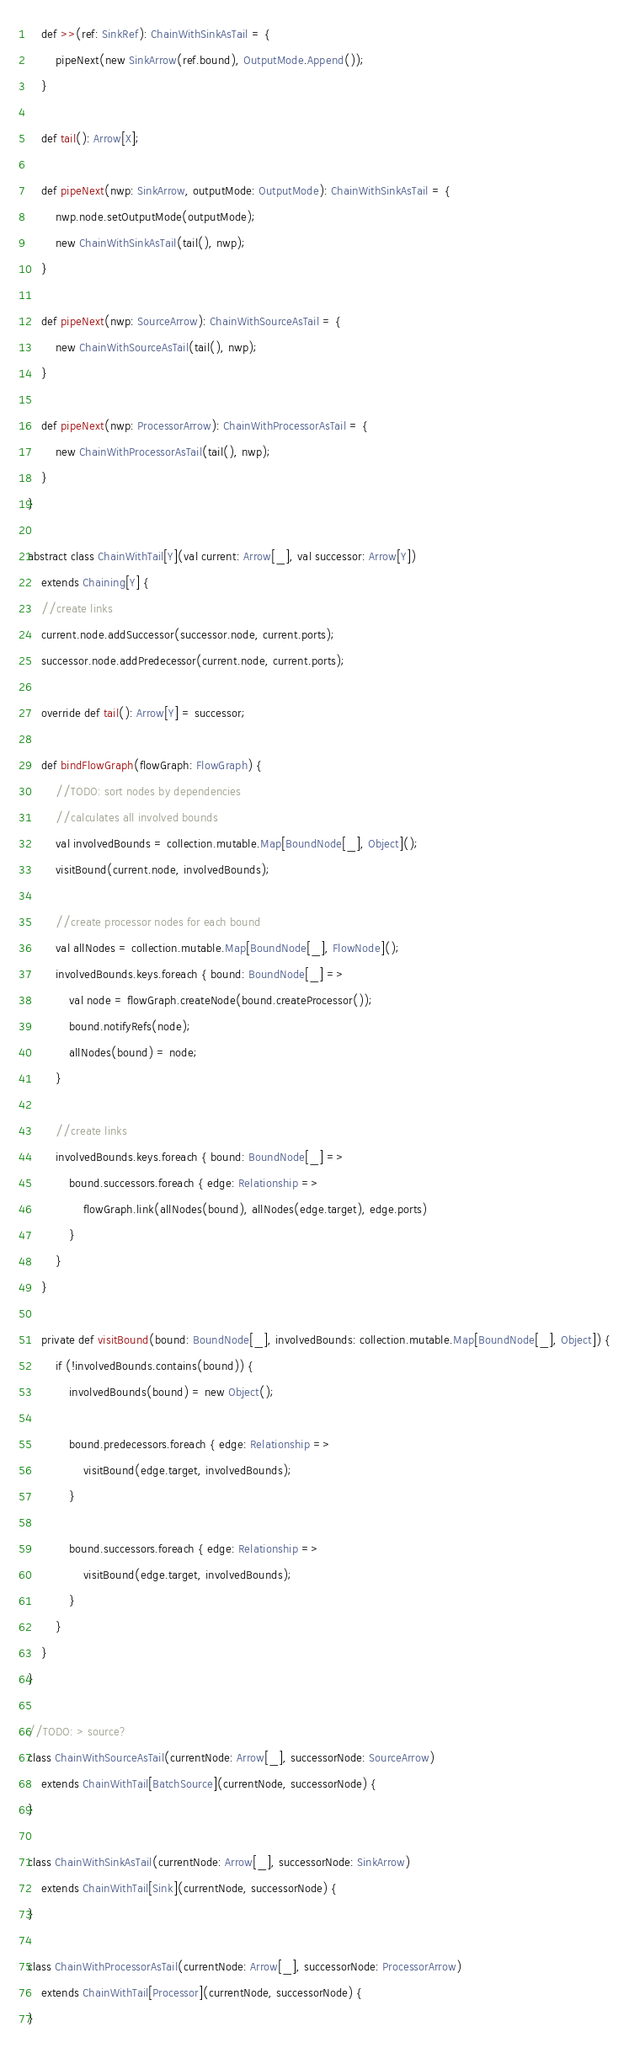<code> <loc_0><loc_0><loc_500><loc_500><_Scala_>	def >>(ref: SinkRef): ChainWithSinkAsTail = {
		pipeNext(new SinkArrow(ref.bound), OutputMode.Append());
	}

	def tail(): Arrow[X];

	def pipeNext(nwp: SinkArrow, outputMode: OutputMode): ChainWithSinkAsTail = {
		nwp.node.setOutputMode(outputMode);
		new ChainWithSinkAsTail(tail(), nwp);
	}

	def pipeNext(nwp: SourceArrow): ChainWithSourceAsTail = {
		new ChainWithSourceAsTail(tail(), nwp);
	}

	def pipeNext(nwp: ProcessorArrow): ChainWithProcessorAsTail = {
		new ChainWithProcessorAsTail(tail(), nwp);
	}
}

abstract class ChainWithTail[Y](val current: Arrow[_], val successor: Arrow[Y])
	extends Chaining[Y] {
	//create links
	current.node.addSuccessor(successor.node, current.ports);
	successor.node.addPredecessor(current.node, current.ports);

	override def tail(): Arrow[Y] = successor;

	def bindFlowGraph(flowGraph: FlowGraph) {
		//TODO: sort nodes by dependencies
		//calculates all involved bounds
		val involvedBounds = collection.mutable.Map[BoundNode[_], Object]();
		visitBound(current.node, involvedBounds);

		//create processor nodes for each bound
		val allNodes = collection.mutable.Map[BoundNode[_], FlowNode]();
		involvedBounds.keys.foreach { bound: BoundNode[_] =>
			val node = flowGraph.createNode(bound.createProcessor());
			bound.notifyRefs(node);
			allNodes(bound) = node;
		}

		//create links
		involvedBounds.keys.foreach { bound: BoundNode[_] =>
			bound.successors.foreach { edge: Relationship =>
				flowGraph.link(allNodes(bound), allNodes(edge.target), edge.ports)
			}
		}
	}

	private def visitBound(bound: BoundNode[_], involvedBounds: collection.mutable.Map[BoundNode[_], Object]) {
		if (!involvedBounds.contains(bound)) {
			involvedBounds(bound) = new Object();

			bound.predecessors.foreach { edge: Relationship =>
				visitBound(edge.target, involvedBounds);
			}

			bound.successors.foreach { edge: Relationship =>
				visitBound(edge.target, involvedBounds);
			}
		}
	}
}

//TODO: > source?
class ChainWithSourceAsTail(currentNode: Arrow[_], successorNode: SourceArrow)
	extends ChainWithTail[BatchSource](currentNode, successorNode) {
}

class ChainWithSinkAsTail(currentNode: Arrow[_], successorNode: SinkArrow)
	extends ChainWithTail[Sink](currentNode, successorNode) {
}

class ChainWithProcessorAsTail(currentNode: Arrow[_], successorNode: ProcessorArrow)
	extends ChainWithTail[Processor](currentNode, successorNode) {
}</code> 